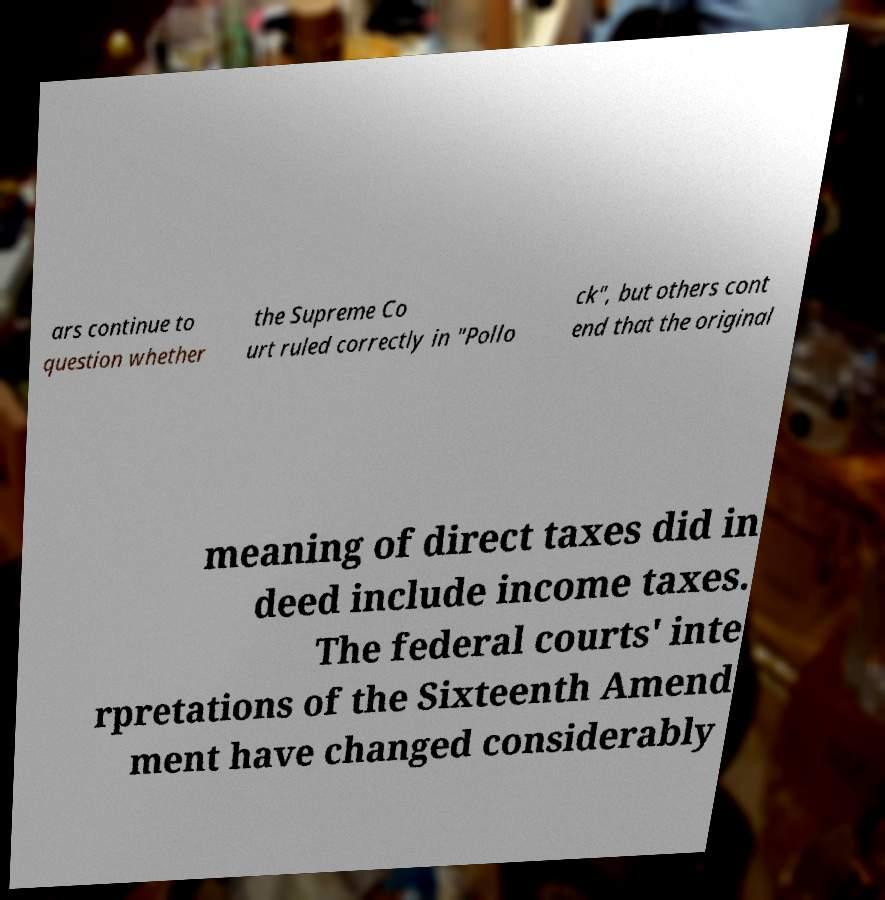For documentation purposes, I need the text within this image transcribed. Could you provide that? ars continue to question whether the Supreme Co urt ruled correctly in "Pollo ck", but others cont end that the original meaning of direct taxes did in deed include income taxes. The federal courts' inte rpretations of the Sixteenth Amend ment have changed considerably 